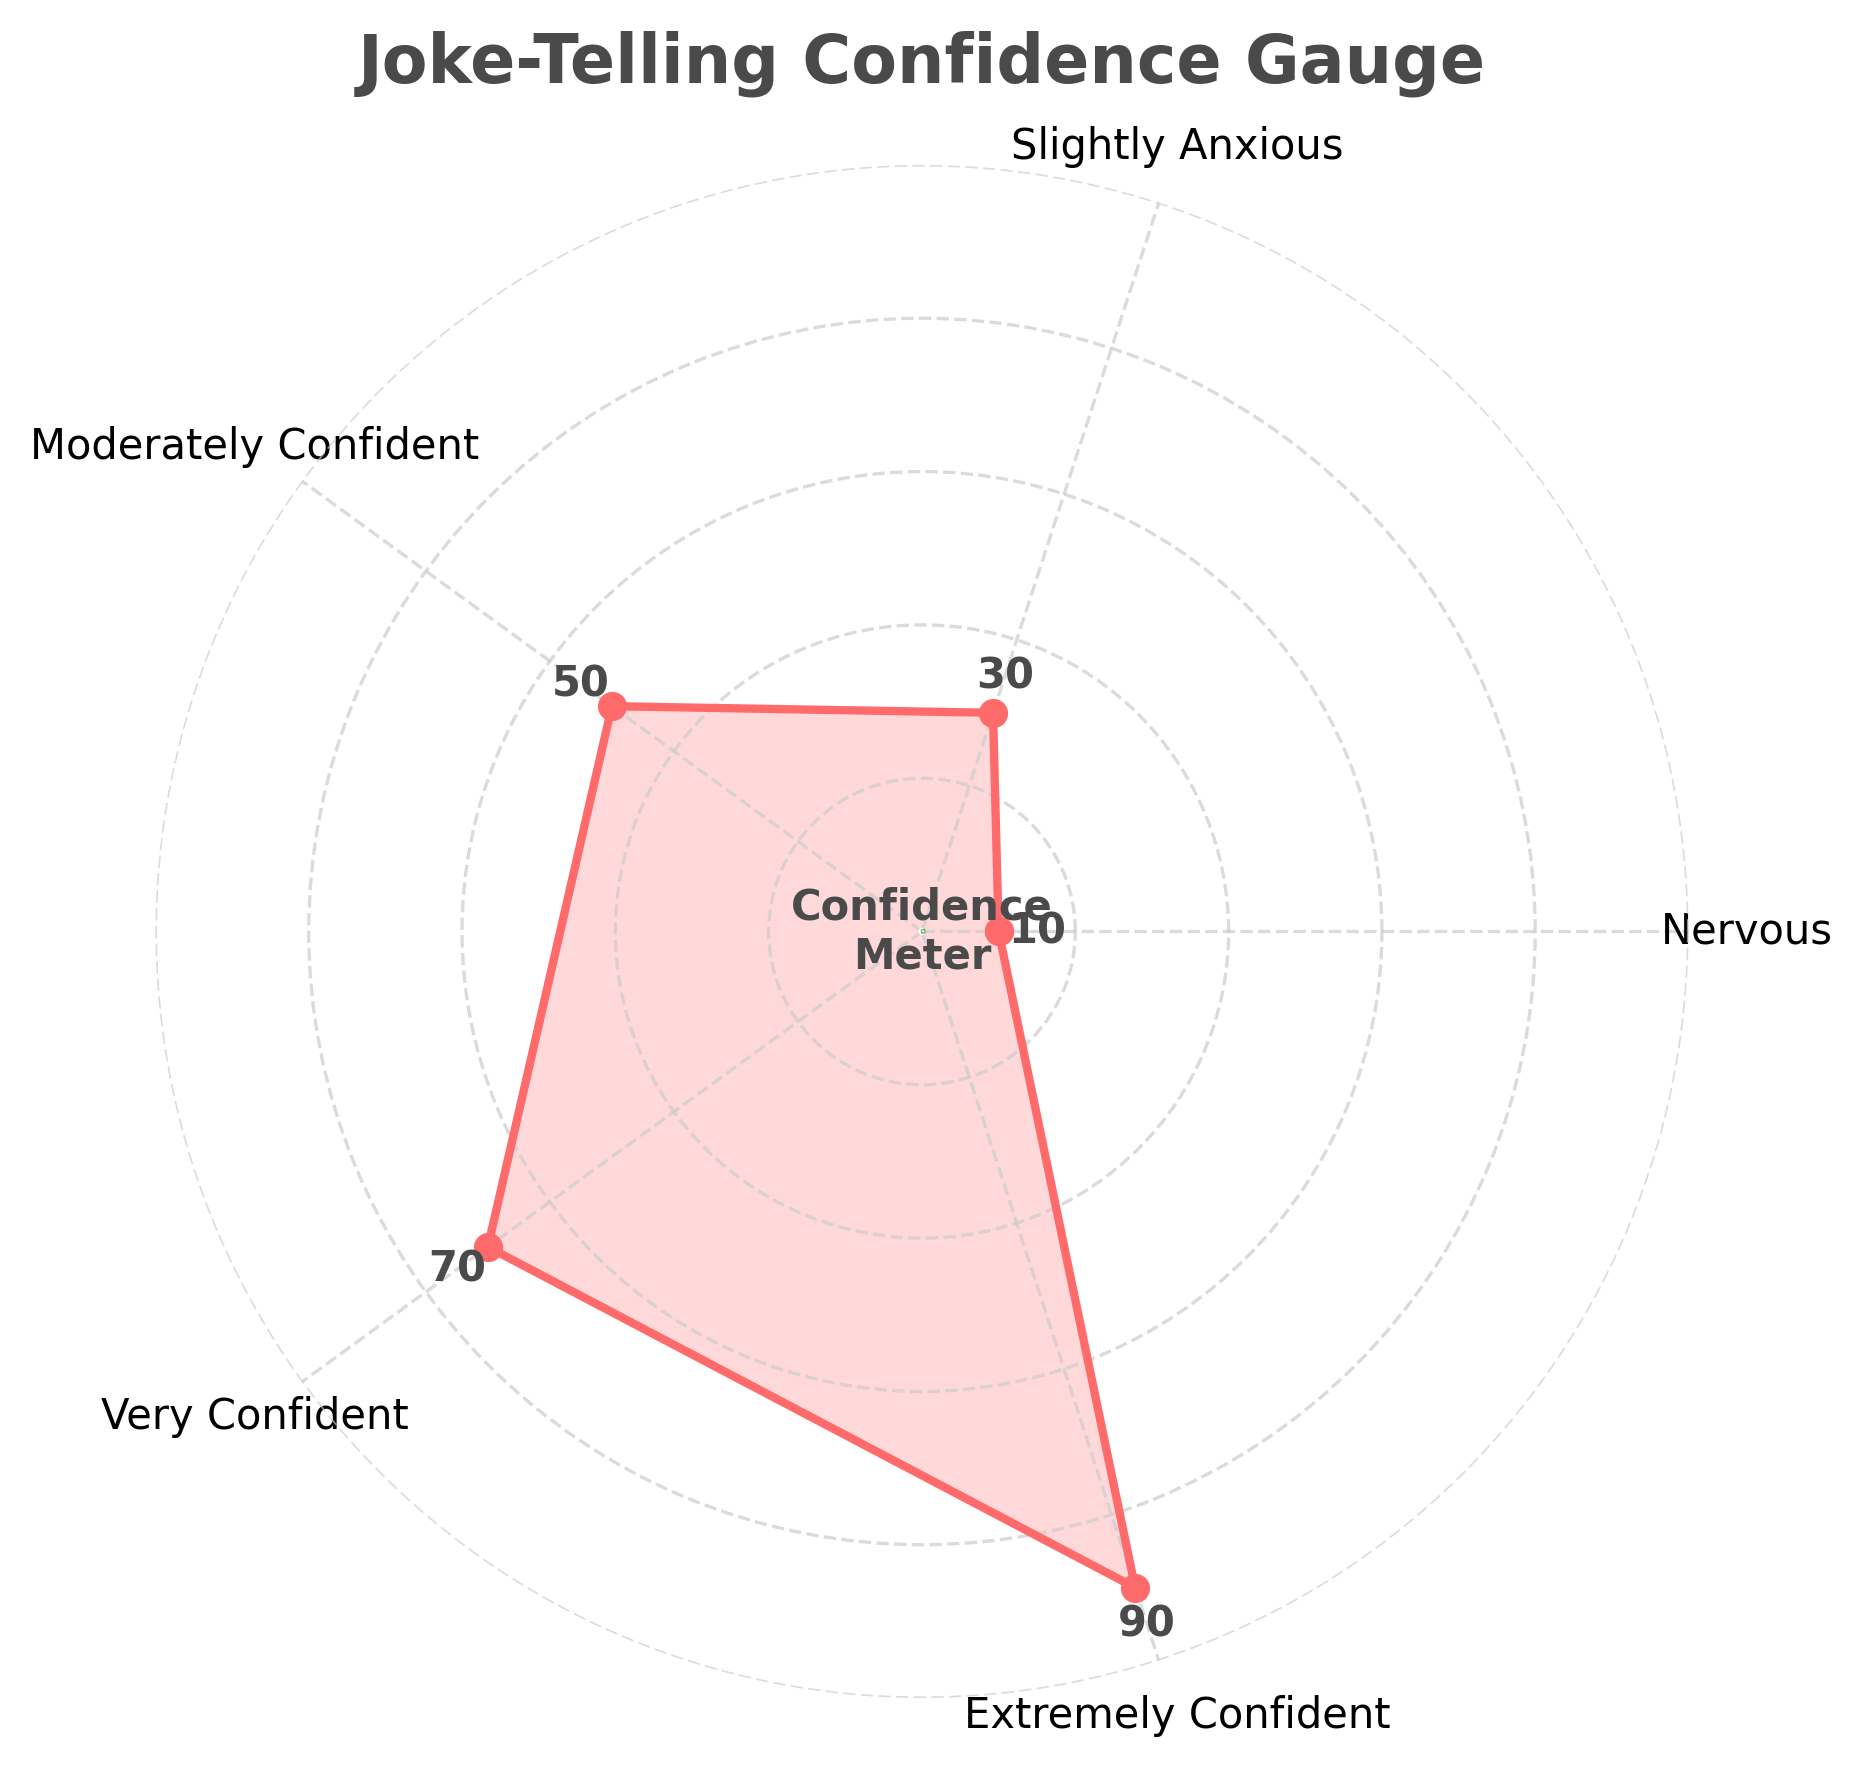Which confidence level has the lowest value? The lowest value is at the position labeled "Nervous" with a value of 10 on the confidence meter.
Answer: Nervous What is the value associated with "Extremely Confident"? The value for "Extremely Confident" is labeled as 90 on the confidence meter.
Answer: 90 How many confidence levels are shown in the chart? Count the number of labeled axes around the gauge chart, which are 5 in total: Nervous, Slightly Anxious, Moderately Confident, Very Confident, and Extremely Confident.
Answer: 5 Which confidence category falls exactly halfway between nervous and extremely confident? The middle category between Nervous (10) and Extremely Confident (90) is "Moderately Confident" with a value of 50.
Answer: Moderately Confident What is the average value of the confidence levels? Adding all values: 10 (Nervous) + 30 (Slightly Anxious) + 50 (Moderately Confident) + 70 (Very Confident) + 90 (Extremely Confident) equals 250. Then, divide by 5: 250/5.
Answer: 50 Which two adjacent confidence levels have the smallest difference? Comparing differences between each pair: Nervous to Slightly Anxious (30-10 = 20), Slightly Anxious to Moderately Confident (50-30 = 20), Moderately Confident to Very Confident (70-50 = 20), Very Confident to Extremely Confident (90-70 = 20). All differences are the same.
Answer: Nervous to Slightly Anxious; Slightly Anxious to Moderately Confident; Moderately Confident to Very Confident; Very Confident to Extremely Confident Which confidence level is twice as confident as Nervous? The value for Nervous is 10. The confidence level with double this value is "Slightly Anxious" with a value of 30 (30 = 2 * 10).
Answer: Slightly Anxious What color is used to fill the area under the plot? The fill color under the plot is a shade of light red.
Answer: Light red What text is written at the center of the gauge chart? The text at the center of the gauge chart is "Confidence Meter".
Answer: Confidence Meter 